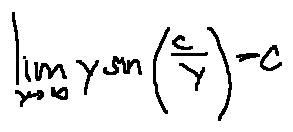Convert formula to latex. <formula><loc_0><loc_0><loc_500><loc_500>\lim \lim i t s _ { y \rightarrow \infty } y \sin ( \frac { c } { y } ) = c</formula> 